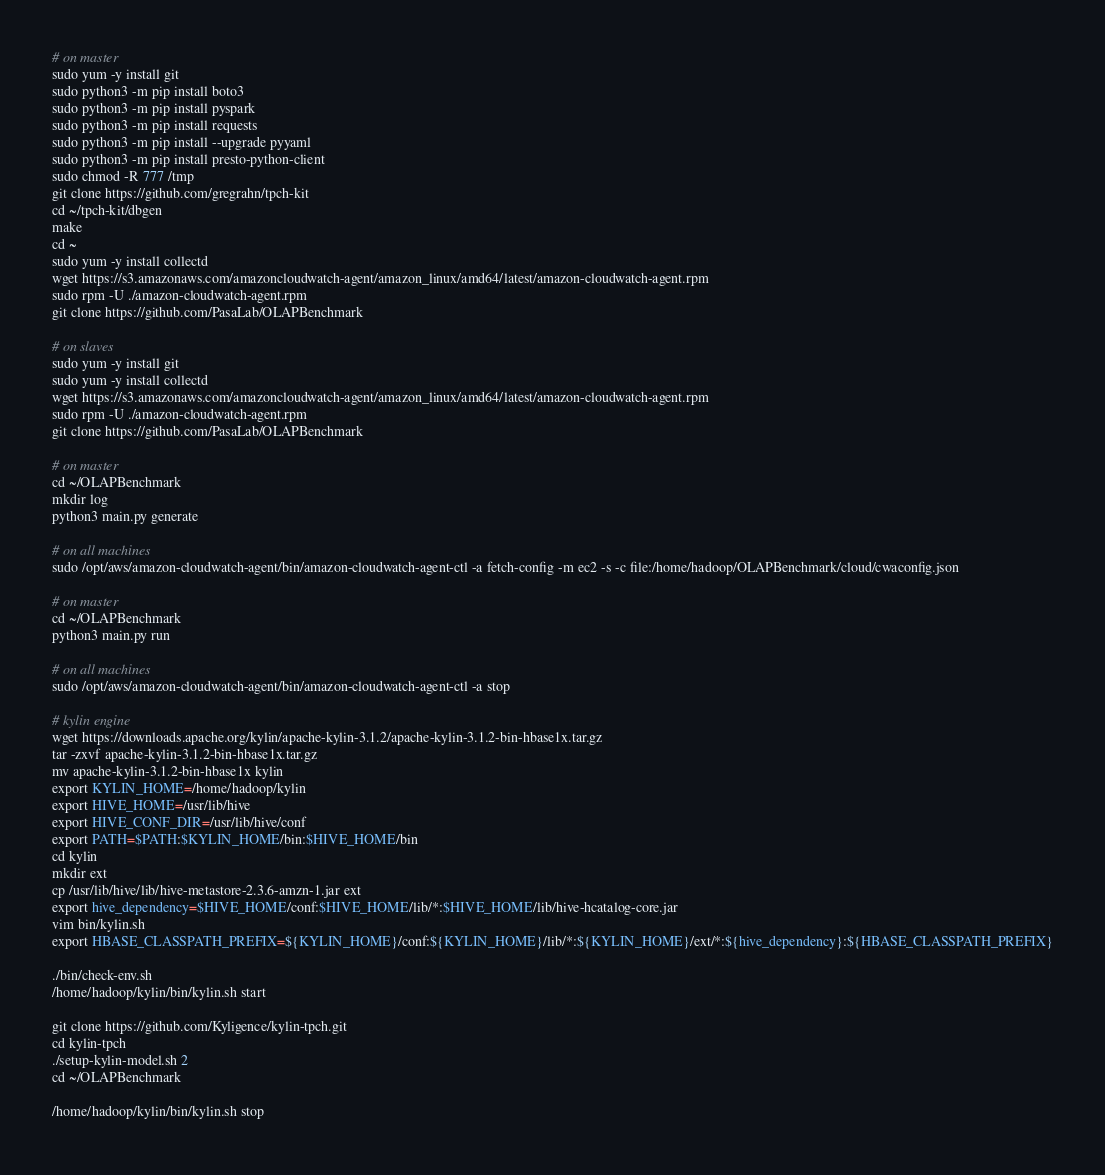Convert code to text. <code><loc_0><loc_0><loc_500><loc_500><_Bash_># on master
sudo yum -y install git
sudo python3 -m pip install boto3
sudo python3 -m pip install pyspark
sudo python3 -m pip install requests
sudo python3 -m pip install --upgrade pyyaml
sudo python3 -m pip install presto-python-client
sudo chmod -R 777 /tmp
git clone https://github.com/gregrahn/tpch-kit
cd ~/tpch-kit/dbgen
make
cd ~
sudo yum -y install collectd
wget https://s3.amazonaws.com/amazoncloudwatch-agent/amazon_linux/amd64/latest/amazon-cloudwatch-agent.rpm
sudo rpm -U ./amazon-cloudwatch-agent.rpm
git clone https://github.com/PasaLab/OLAPBenchmark

# on slaves
sudo yum -y install git
sudo yum -y install collectd
wget https://s3.amazonaws.com/amazoncloudwatch-agent/amazon_linux/amd64/latest/amazon-cloudwatch-agent.rpm
sudo rpm -U ./amazon-cloudwatch-agent.rpm
git clone https://github.com/PasaLab/OLAPBenchmark

# on master
cd ~/OLAPBenchmark
mkdir log
python3 main.py generate

# on all machines
sudo /opt/aws/amazon-cloudwatch-agent/bin/amazon-cloudwatch-agent-ctl -a fetch-config -m ec2 -s -c file:/home/hadoop/OLAPBenchmark/cloud/cwaconfig.json

# on master
cd ~/OLAPBenchmark
python3 main.py run

# on all machines
sudo /opt/aws/amazon-cloudwatch-agent/bin/amazon-cloudwatch-agent-ctl -a stop

# kylin engine
wget https://downloads.apache.org/kylin/apache-kylin-3.1.2/apache-kylin-3.1.2-bin-hbase1x.tar.gz
tar -zxvf apache-kylin-3.1.2-bin-hbase1x.tar.gz
mv apache-kylin-3.1.2-bin-hbase1x kylin
export KYLIN_HOME=/home/hadoop/kylin
export HIVE_HOME=/usr/lib/hive
export HIVE_CONF_DIR=/usr/lib/hive/conf
export PATH=$PATH:$KYLIN_HOME/bin:$HIVE_HOME/bin
cd kylin
mkdir ext
cp /usr/lib/hive/lib/hive-metastore-2.3.6-amzn-1.jar ext
export hive_dependency=$HIVE_HOME/conf:$HIVE_HOME/lib/*:$HIVE_HOME/lib/hive-hcatalog-core.jar
vim bin/kylin.sh
export HBASE_CLASSPATH_PREFIX=${KYLIN_HOME}/conf:${KYLIN_HOME}/lib/*:${KYLIN_HOME}/ext/*:${hive_dependency}:${HBASE_CLASSPATH_PREFIX}

./bin/check-env.sh
/home/hadoop/kylin/bin/kylin.sh start

git clone https://github.com/Kyligence/kylin-tpch.git
cd kylin-tpch
./setup-kylin-model.sh 2
cd ~/OLAPBenchmark

/home/hadoop/kylin/bin/kylin.sh stop
</code> 